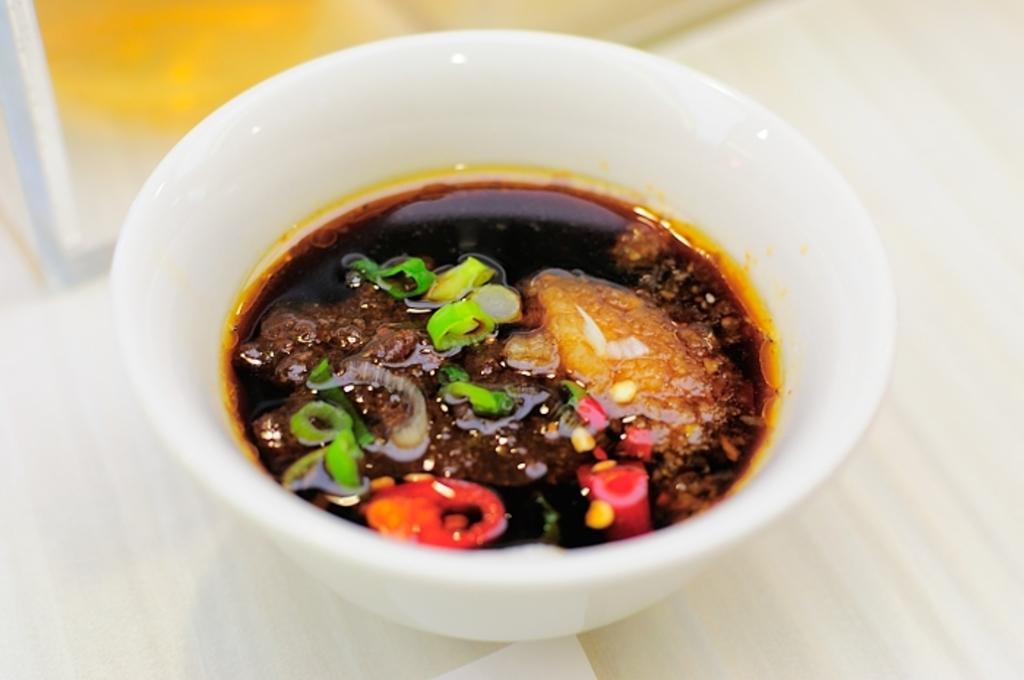How would you summarize this image in a sentence or two? In this image we can see food in a bowl which is on the platform. 